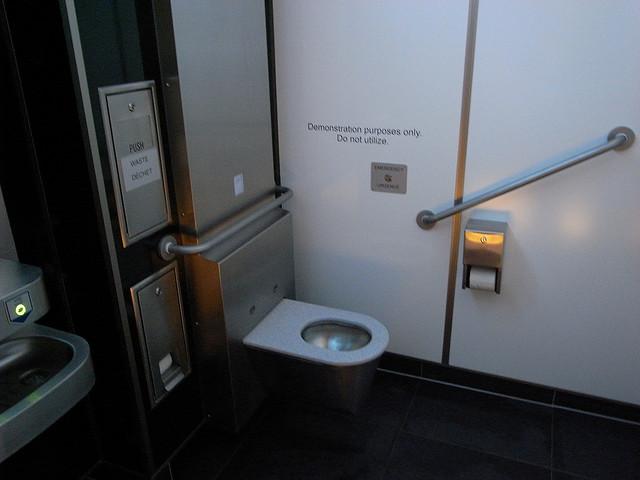Is there a rug on the floor?
Keep it brief. No. What are the words on the door?
Concise answer only. Do not utilize. Where is the sink?
Give a very brief answer. Left. Is the trash can full?
Keep it brief. No. What is the metal object to the left?
Answer briefly. Sink. Is this a safe toilet?
Keep it brief. Yes. What kind of picture are on the wall?
Concise answer only. None. Is there daylight?
Give a very brief answer. No. What color is the sink?
Quick response, please. Silver. What color is the toilet?
Keep it brief. Silver. Is the gold line vertical or horizontal?
Give a very brief answer. Vertical. What color is the toilet bowl in this scene?
Short answer required. Silver. 